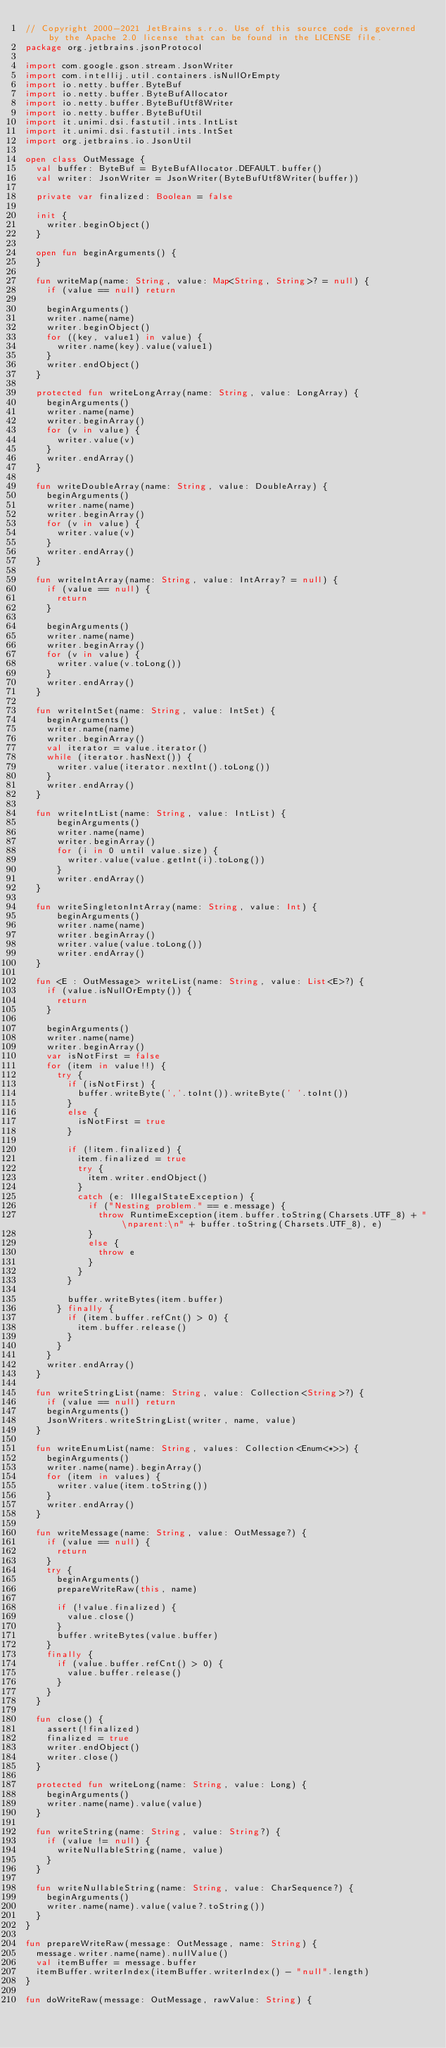Convert code to text. <code><loc_0><loc_0><loc_500><loc_500><_Kotlin_>// Copyright 2000-2021 JetBrains s.r.o. Use of this source code is governed by the Apache 2.0 license that can be found in the LICENSE file.
package org.jetbrains.jsonProtocol

import com.google.gson.stream.JsonWriter
import com.intellij.util.containers.isNullOrEmpty
import io.netty.buffer.ByteBuf
import io.netty.buffer.ByteBufAllocator
import io.netty.buffer.ByteBufUtf8Writer
import io.netty.buffer.ByteBufUtil
import it.unimi.dsi.fastutil.ints.IntList
import it.unimi.dsi.fastutil.ints.IntSet
import org.jetbrains.io.JsonUtil

open class OutMessage {
  val buffer: ByteBuf = ByteBufAllocator.DEFAULT.buffer()
  val writer: JsonWriter = JsonWriter(ByteBufUtf8Writer(buffer))

  private var finalized: Boolean = false

  init {
    writer.beginObject()
  }

  open fun beginArguments() {
  }

  fun writeMap(name: String, value: Map<String, String>? = null) {
    if (value == null) return

    beginArguments()
    writer.name(name)
    writer.beginObject()
    for ((key, value1) in value) {
      writer.name(key).value(value1)
    }
    writer.endObject()
  }

  protected fun writeLongArray(name: String, value: LongArray) {
    beginArguments()
    writer.name(name)
    writer.beginArray()
    for (v in value) {
      writer.value(v)
    }
    writer.endArray()
  }

  fun writeDoubleArray(name: String, value: DoubleArray) {
    beginArguments()
    writer.name(name)
    writer.beginArray()
    for (v in value) {
      writer.value(v)
    }
    writer.endArray()
  }

  fun writeIntArray(name: String, value: IntArray? = null) {
    if (value == null) {
      return
    }

    beginArguments()
    writer.name(name)
    writer.beginArray()
    for (v in value) {
      writer.value(v.toLong())
    }
    writer.endArray()
  }

  fun writeIntSet(name: String, value: IntSet) {
    beginArguments()
    writer.name(name)
    writer.beginArray()
    val iterator = value.iterator()
    while (iterator.hasNext()) {
      writer.value(iterator.nextInt().toLong())
    }
    writer.endArray()
  }

  fun writeIntList(name: String, value: IntList) {
      beginArguments()
      writer.name(name)
      writer.beginArray()
      for (i in 0 until value.size) {
        writer.value(value.getInt(i).toLong())
      }
      writer.endArray()
  }

  fun writeSingletonIntArray(name: String, value: Int) {
      beginArguments()
      writer.name(name)
      writer.beginArray()
      writer.value(value.toLong())
      writer.endArray()
  }

  fun <E : OutMessage> writeList(name: String, value: List<E>?) {
    if (value.isNullOrEmpty()) {
      return
    }

    beginArguments()
    writer.name(name)
    writer.beginArray()
    var isNotFirst = false
    for (item in value!!) {
      try {
        if (isNotFirst) {
          buffer.writeByte(','.toInt()).writeByte(' '.toInt())
        }
        else {
          isNotFirst = true
        }

        if (!item.finalized) {
          item.finalized = true
          try {
            item.writer.endObject()
          }
          catch (e: IllegalStateException) {
            if ("Nesting problem." == e.message) {
              throw RuntimeException(item.buffer.toString(Charsets.UTF_8) + "\nparent:\n" + buffer.toString(Charsets.UTF_8), e)
            }
            else {
              throw e
            }
          }
        }

        buffer.writeBytes(item.buffer)
      } finally {
        if (item.buffer.refCnt() > 0) {
          item.buffer.release()
        }
      }
    }
    writer.endArray()
  }

  fun writeStringList(name: String, value: Collection<String>?) {
    if (value == null) return
    beginArguments()
    JsonWriters.writeStringList(writer, name, value)
  }

  fun writeEnumList(name: String, values: Collection<Enum<*>>) {
    beginArguments()
    writer.name(name).beginArray()
    for (item in values) {
      writer.value(item.toString())
    }
    writer.endArray()
  }

  fun writeMessage(name: String, value: OutMessage?) {
    if (value == null) {
      return
    }
    try {
      beginArguments()
      prepareWriteRaw(this, name)

      if (!value.finalized) {
        value.close()
      }
      buffer.writeBytes(value.buffer)
    }
    finally {
      if (value.buffer.refCnt() > 0) {
        value.buffer.release()
      }
    }
  }

  fun close() {
    assert(!finalized)
    finalized = true
    writer.endObject()
    writer.close()
  }

  protected fun writeLong(name: String, value: Long) {
    beginArguments()
    writer.name(name).value(value)
  }

  fun writeString(name: String, value: String?) {
    if (value != null) {
      writeNullableString(name, value)
    }
  }

  fun writeNullableString(name: String, value: CharSequence?) {
    beginArguments()
    writer.name(name).value(value?.toString())
  }
}

fun prepareWriteRaw(message: OutMessage, name: String) {
  message.writer.name(name).nullValue()
  val itemBuffer = message.buffer
  itemBuffer.writerIndex(itemBuffer.writerIndex() - "null".length)
}

fun doWriteRaw(message: OutMessage, rawValue: String) {</code> 